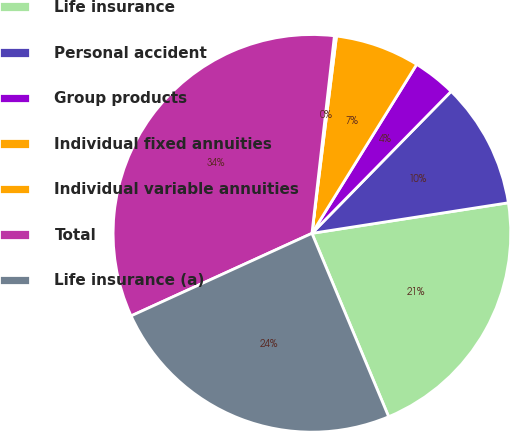Convert chart to OTSL. <chart><loc_0><loc_0><loc_500><loc_500><pie_chart><fcel>Life insurance<fcel>Personal accident<fcel>Group products<fcel>Individual fixed annuities<fcel>Individual variable annuities<fcel>Total<fcel>Life insurance (a)<nl><fcel>21.15%<fcel>10.2%<fcel>3.51%<fcel>6.86%<fcel>0.17%<fcel>33.62%<fcel>24.49%<nl></chart> 